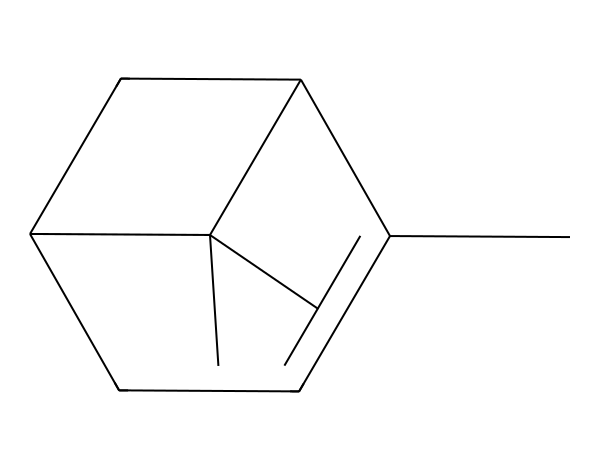How many carbon atoms are in α-pinene? The SMILES representation indicates that there are 10 carbon atoms (C) in total. Each "C" in the representation corresponds to a carbon atom, and by counting them, we find there are 10.
Answer: 10 What is the degree of unsaturation for α-pinene? To calculate the degree of unsaturation, we use the formula: Degree of Unsaturation = (2C + 2 + N - H - X)/2. For α-pinene (10 carbons, 16 hydrogens), this results in (2(10) + 2 - 16)/2 = 3. Thus, α-pinene has 3 degrees of unsaturation, indicating that it contains rings or double bonds.
Answer: 3 What is the functional group present in α-pinene? The structure contains a double bond (due to the presence of degree of unsaturation) but does not contain a specific functional group like alcohol or ketone, as it is classified primarily as a terpene. It's recognizable by the cyclic structure common in many terpenes.
Answer: none Is α-pinene a cyclic compound? The defined structure shows a ring formation (noted by the "C1" and "C2"), confirming that it is a cyclic compound. This characteristic is typical of many terpenes.
Answer: yes Which type of molecule is α-pinene? α-pinene belongs to the category of terpenes, which are organic compounds produced by various plants and are often responsible for their aroma. This classification helps in identifying its ecological and functional roles.
Answer: terpene What type of isomerism does α-pinene exhibit? α-pinene shows stereoisomerism because it has a chiral center (a carbon attached to four different substituents), which leads to the existence of different stereoisomers (enantiomers). This is common in molecules that have such arrangements.
Answer: stereoisomerism 